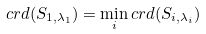Convert formula to latex. <formula><loc_0><loc_0><loc_500><loc_500>c r d ( S _ { 1 , \lambda _ { 1 } } ) = \min _ { i } c r d ( S _ { i , \lambda _ { i } } )</formula> 